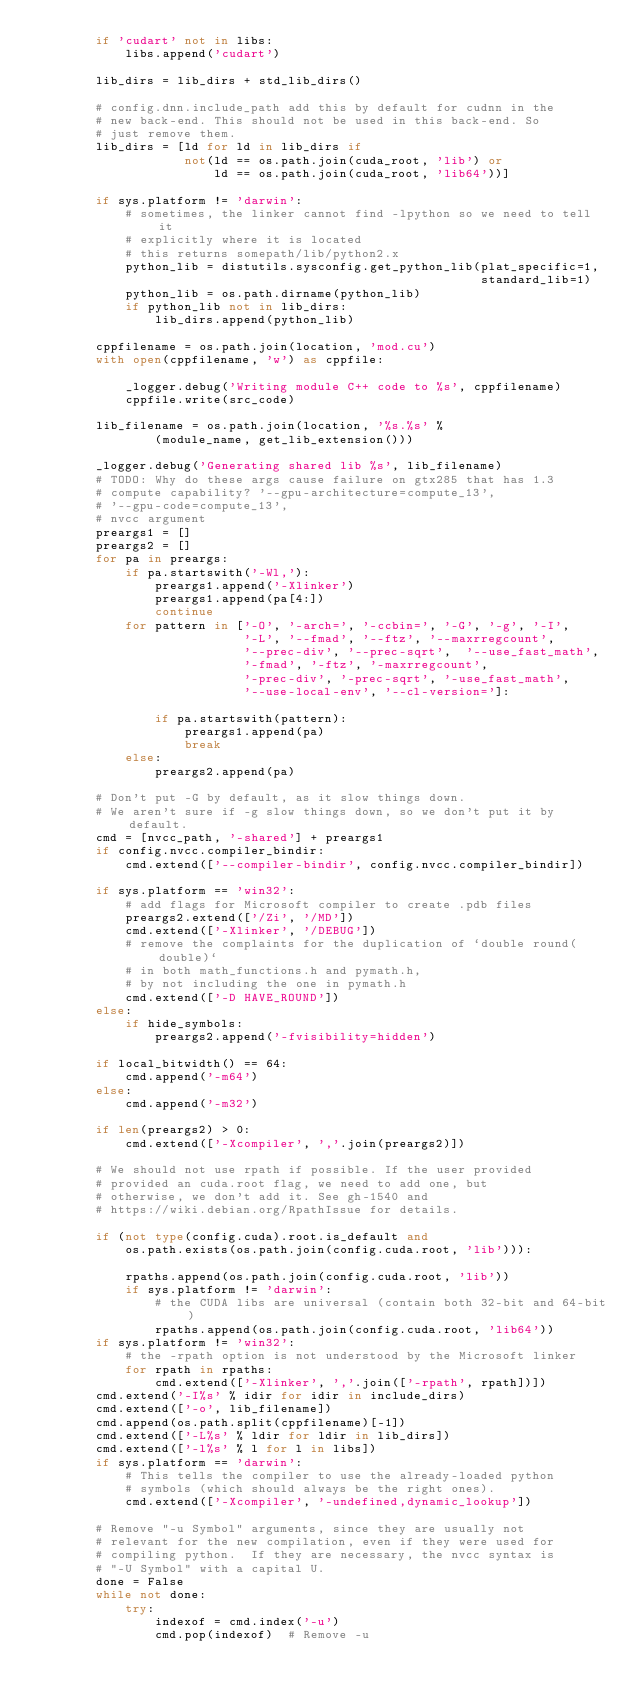Convert code to text. <code><loc_0><loc_0><loc_500><loc_500><_Python_>        if 'cudart' not in libs:
            libs.append('cudart')

        lib_dirs = lib_dirs + std_lib_dirs()

        # config.dnn.include_path add this by default for cudnn in the
        # new back-end. This should not be used in this back-end. So
        # just remove them.
        lib_dirs = [ld for ld in lib_dirs if
                    not(ld == os.path.join(cuda_root, 'lib') or
                        ld == os.path.join(cuda_root, 'lib64'))]

        if sys.platform != 'darwin':
            # sometimes, the linker cannot find -lpython so we need to tell it
            # explicitly where it is located
            # this returns somepath/lib/python2.x
            python_lib = distutils.sysconfig.get_python_lib(plat_specific=1,
                                                            standard_lib=1)
            python_lib = os.path.dirname(python_lib)
            if python_lib not in lib_dirs:
                lib_dirs.append(python_lib)

        cppfilename = os.path.join(location, 'mod.cu')
        with open(cppfilename, 'w') as cppfile:

            _logger.debug('Writing module C++ code to %s', cppfilename)
            cppfile.write(src_code)

        lib_filename = os.path.join(location, '%s.%s' %
                (module_name, get_lib_extension()))

        _logger.debug('Generating shared lib %s', lib_filename)
        # TODO: Why do these args cause failure on gtx285 that has 1.3
        # compute capability? '--gpu-architecture=compute_13',
        # '--gpu-code=compute_13',
        # nvcc argument
        preargs1 = []
        preargs2 = []
        for pa in preargs:
            if pa.startswith('-Wl,'):
                preargs1.append('-Xlinker')
                preargs1.append(pa[4:])
                continue
            for pattern in ['-O', '-arch=', '-ccbin=', '-G', '-g', '-I',
                            '-L', '--fmad', '--ftz', '--maxrregcount',
                            '--prec-div', '--prec-sqrt',  '--use_fast_math',
                            '-fmad', '-ftz', '-maxrregcount',
                            '-prec-div', '-prec-sqrt', '-use_fast_math',
                            '--use-local-env', '--cl-version=']:

                if pa.startswith(pattern):
                    preargs1.append(pa)
                    break
            else:
                preargs2.append(pa)

        # Don't put -G by default, as it slow things down.
        # We aren't sure if -g slow things down, so we don't put it by default.
        cmd = [nvcc_path, '-shared'] + preargs1
        if config.nvcc.compiler_bindir:
            cmd.extend(['--compiler-bindir', config.nvcc.compiler_bindir])

        if sys.platform == 'win32':
            # add flags for Microsoft compiler to create .pdb files
            preargs2.extend(['/Zi', '/MD'])
            cmd.extend(['-Xlinker', '/DEBUG'])
            # remove the complaints for the duplication of `double round(double)`
            # in both math_functions.h and pymath.h,
            # by not including the one in pymath.h
            cmd.extend(['-D HAVE_ROUND'])
        else:
            if hide_symbols:
                preargs2.append('-fvisibility=hidden')

        if local_bitwidth() == 64:
            cmd.append('-m64')
        else:
            cmd.append('-m32')

        if len(preargs2) > 0:
            cmd.extend(['-Xcompiler', ','.join(preargs2)])

        # We should not use rpath if possible. If the user provided
        # provided an cuda.root flag, we need to add one, but
        # otherwise, we don't add it. See gh-1540 and
        # https://wiki.debian.org/RpathIssue for details.

        if (not type(config.cuda).root.is_default and
            os.path.exists(os.path.join(config.cuda.root, 'lib'))):

            rpaths.append(os.path.join(config.cuda.root, 'lib'))
            if sys.platform != 'darwin':
                # the CUDA libs are universal (contain both 32-bit and 64-bit)
                rpaths.append(os.path.join(config.cuda.root, 'lib64'))
        if sys.platform != 'win32':
            # the -rpath option is not understood by the Microsoft linker
            for rpath in rpaths:
                cmd.extend(['-Xlinker', ','.join(['-rpath', rpath])])
        cmd.extend('-I%s' % idir for idir in include_dirs)
        cmd.extend(['-o', lib_filename])
        cmd.append(os.path.split(cppfilename)[-1])
        cmd.extend(['-L%s' % ldir for ldir in lib_dirs])
        cmd.extend(['-l%s' % l for l in libs])
        if sys.platform == 'darwin':
            # This tells the compiler to use the already-loaded python
            # symbols (which should always be the right ones).
            cmd.extend(['-Xcompiler', '-undefined,dynamic_lookup'])

        # Remove "-u Symbol" arguments, since they are usually not
        # relevant for the new compilation, even if they were used for
        # compiling python.  If they are necessary, the nvcc syntax is
        # "-U Symbol" with a capital U.
        done = False
        while not done:
            try:
                indexof = cmd.index('-u')
                cmd.pop(indexof)  # Remove -u</code> 